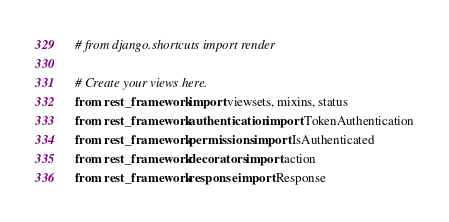Convert code to text. <code><loc_0><loc_0><loc_500><loc_500><_Python_># from django.shortcuts import render

# Create your views here.
from rest_framework import viewsets, mixins, status
from rest_framework.authentication import TokenAuthentication
from rest_framework.permissions import IsAuthenticated
from rest_framework.decorators import action
from rest_framework.response import Response
</code> 